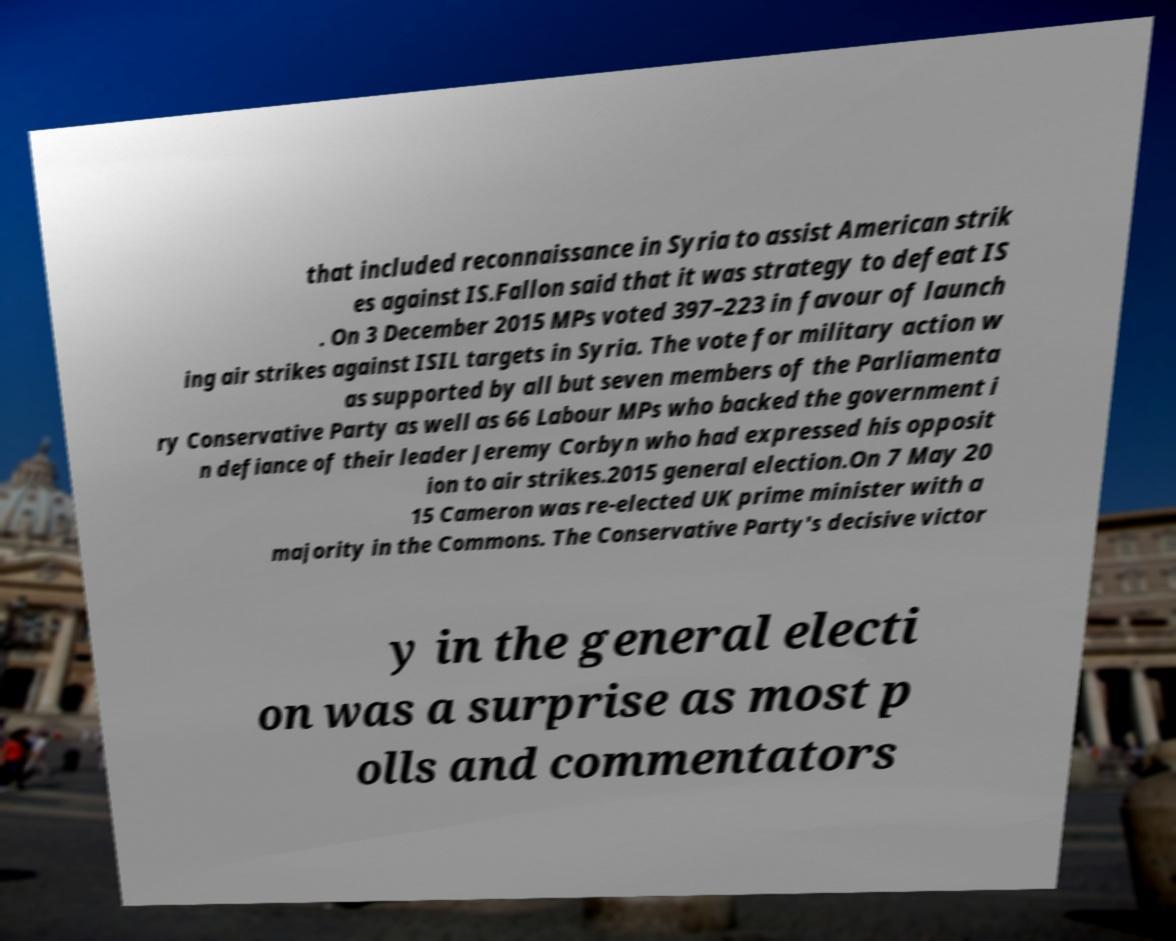Could you extract and type out the text from this image? that included reconnaissance in Syria to assist American strik es against IS.Fallon said that it was strategy to defeat IS . On 3 December 2015 MPs voted 397–223 in favour of launch ing air strikes against ISIL targets in Syria. The vote for military action w as supported by all but seven members of the Parliamenta ry Conservative Party as well as 66 Labour MPs who backed the government i n defiance of their leader Jeremy Corbyn who had expressed his opposit ion to air strikes.2015 general election.On 7 May 20 15 Cameron was re-elected UK prime minister with a majority in the Commons. The Conservative Party's decisive victor y in the general electi on was a surprise as most p olls and commentators 